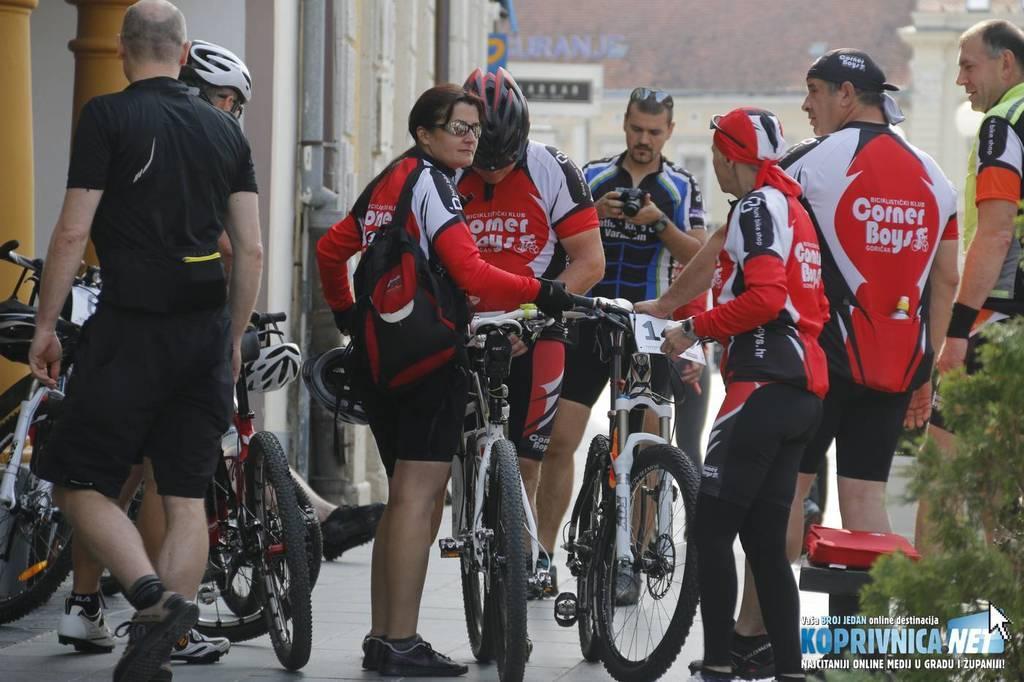Can you describe this image briefly? On the background we can see building. These are pillars. We can see all the persons standing on the road and few are sitting on a bicycle wearing helmets. At the right side of the picture we can see a plant. 